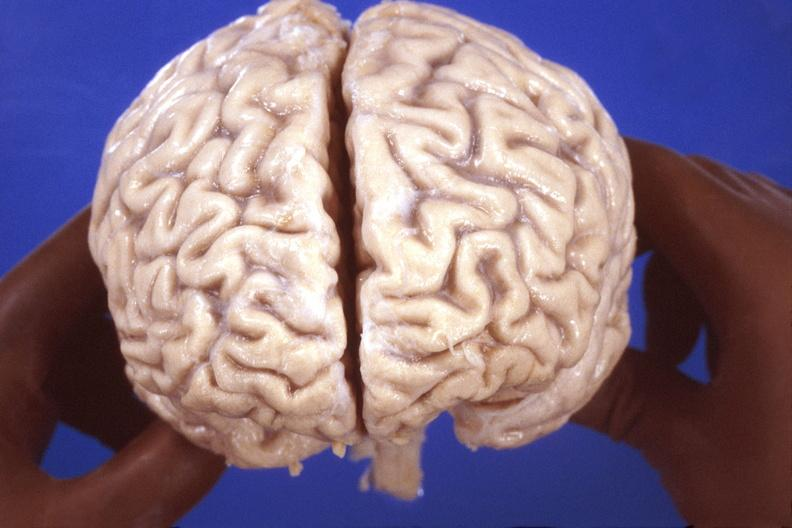does fracture show brain, hiv neuropathy, atrophy?
Answer the question using a single word or phrase. No 